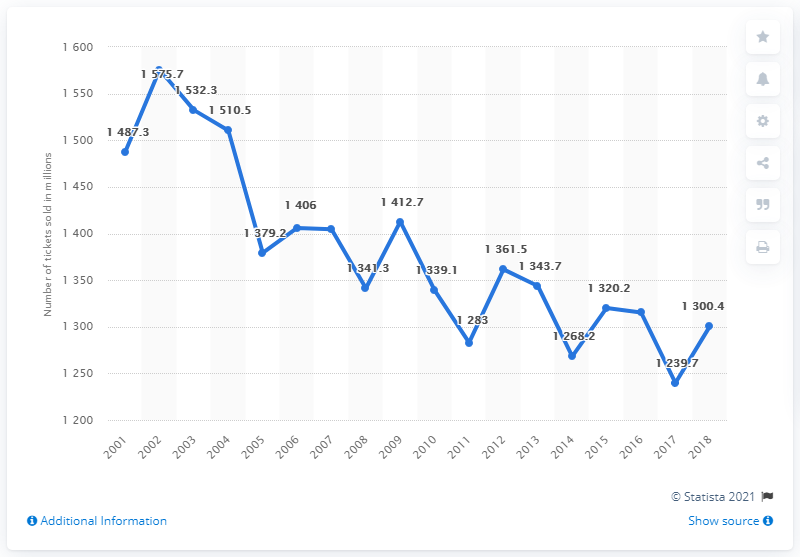Identify some key points in this picture. In the United States and Canada in 2005, a total of 1,379.2 movie tickets were sold. In the year 2002, the line graph reached its highest peak. The difference between the maximum and minimum number of tickets sold over the years is 336. In 2018, approximately 1,300.4 movie tickets were sold in theaters. 